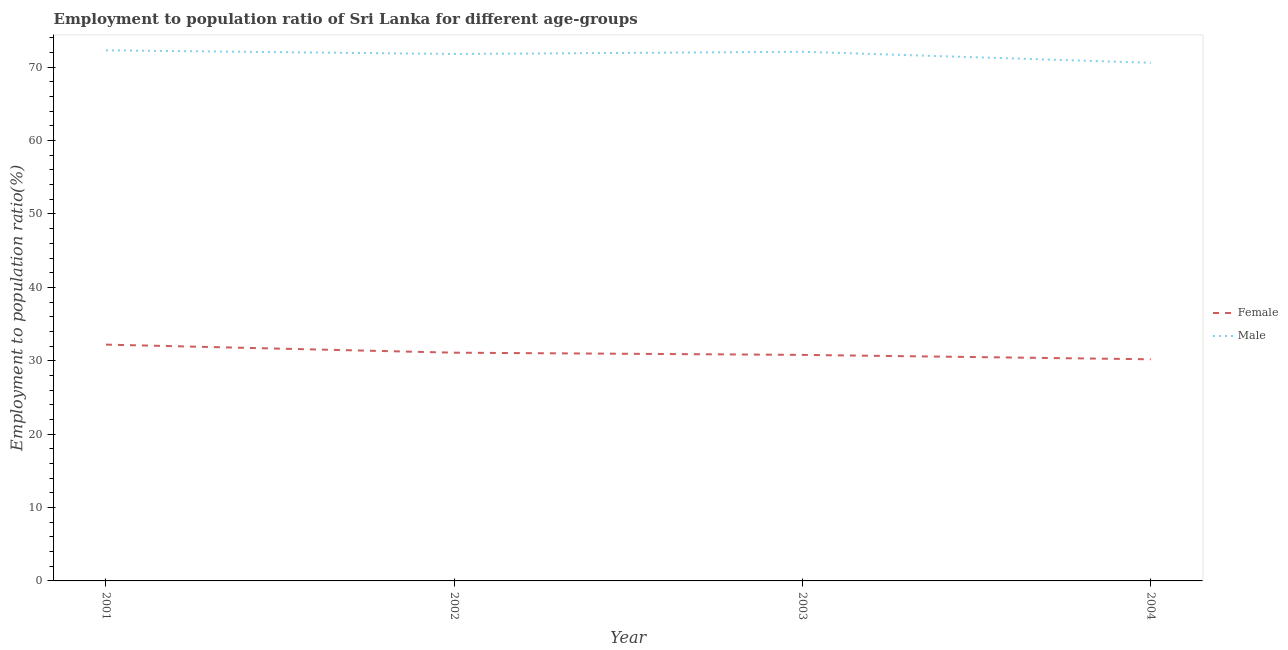How many different coloured lines are there?
Provide a succinct answer. 2. Does the line corresponding to employment to population ratio(female) intersect with the line corresponding to employment to population ratio(male)?
Your answer should be very brief. No. What is the employment to population ratio(male) in 2001?
Your response must be concise. 72.3. Across all years, what is the maximum employment to population ratio(male)?
Provide a short and direct response. 72.3. Across all years, what is the minimum employment to population ratio(male)?
Offer a very short reply. 70.6. In which year was the employment to population ratio(female) maximum?
Offer a terse response. 2001. What is the total employment to population ratio(female) in the graph?
Your response must be concise. 124.3. What is the difference between the employment to population ratio(female) in 2002 and that in 2003?
Provide a short and direct response. 0.3. What is the difference between the employment to population ratio(female) in 2003 and the employment to population ratio(male) in 2002?
Provide a short and direct response. -41. What is the average employment to population ratio(male) per year?
Offer a very short reply. 71.7. In the year 2003, what is the difference between the employment to population ratio(male) and employment to population ratio(female)?
Make the answer very short. 41.3. In how many years, is the employment to population ratio(female) greater than 22 %?
Provide a succinct answer. 4. What is the ratio of the employment to population ratio(male) in 2001 to that in 2002?
Your answer should be very brief. 1.01. Is the difference between the employment to population ratio(male) in 2001 and 2003 greater than the difference between the employment to population ratio(female) in 2001 and 2003?
Give a very brief answer. No. What is the difference between the highest and the second highest employment to population ratio(male)?
Your response must be concise. 0.2. What is the difference between the highest and the lowest employment to population ratio(male)?
Keep it short and to the point. 1.7. How many lines are there?
Offer a very short reply. 2. Does the graph contain grids?
Provide a succinct answer. No. How are the legend labels stacked?
Make the answer very short. Vertical. What is the title of the graph?
Ensure brevity in your answer.  Employment to population ratio of Sri Lanka for different age-groups. Does "From World Bank" appear as one of the legend labels in the graph?
Offer a very short reply. No. What is the label or title of the X-axis?
Your answer should be compact. Year. What is the Employment to population ratio(%) of Female in 2001?
Ensure brevity in your answer.  32.2. What is the Employment to population ratio(%) in Male in 2001?
Offer a very short reply. 72.3. What is the Employment to population ratio(%) in Female in 2002?
Give a very brief answer. 31.1. What is the Employment to population ratio(%) in Male in 2002?
Provide a succinct answer. 71.8. What is the Employment to population ratio(%) of Female in 2003?
Provide a succinct answer. 30.8. What is the Employment to population ratio(%) of Male in 2003?
Keep it short and to the point. 72.1. What is the Employment to population ratio(%) of Female in 2004?
Your response must be concise. 30.2. What is the Employment to population ratio(%) in Male in 2004?
Your response must be concise. 70.6. Across all years, what is the maximum Employment to population ratio(%) in Female?
Make the answer very short. 32.2. Across all years, what is the maximum Employment to population ratio(%) of Male?
Keep it short and to the point. 72.3. Across all years, what is the minimum Employment to population ratio(%) of Female?
Offer a terse response. 30.2. Across all years, what is the minimum Employment to population ratio(%) in Male?
Give a very brief answer. 70.6. What is the total Employment to population ratio(%) in Female in the graph?
Your answer should be very brief. 124.3. What is the total Employment to population ratio(%) in Male in the graph?
Ensure brevity in your answer.  286.8. What is the difference between the Employment to population ratio(%) in Male in 2001 and that in 2003?
Your answer should be compact. 0.2. What is the difference between the Employment to population ratio(%) of Female in 2001 and that in 2004?
Keep it short and to the point. 2. What is the difference between the Employment to population ratio(%) in Male in 2001 and that in 2004?
Provide a short and direct response. 1.7. What is the difference between the Employment to population ratio(%) in Female in 2002 and that in 2003?
Offer a terse response. 0.3. What is the difference between the Employment to population ratio(%) of Male in 2002 and that in 2003?
Make the answer very short. -0.3. What is the difference between the Employment to population ratio(%) in Male in 2002 and that in 2004?
Offer a terse response. 1.2. What is the difference between the Employment to population ratio(%) of Male in 2003 and that in 2004?
Make the answer very short. 1.5. What is the difference between the Employment to population ratio(%) of Female in 2001 and the Employment to population ratio(%) of Male in 2002?
Offer a terse response. -39.6. What is the difference between the Employment to population ratio(%) in Female in 2001 and the Employment to population ratio(%) in Male in 2003?
Offer a very short reply. -39.9. What is the difference between the Employment to population ratio(%) of Female in 2001 and the Employment to population ratio(%) of Male in 2004?
Offer a very short reply. -38.4. What is the difference between the Employment to population ratio(%) in Female in 2002 and the Employment to population ratio(%) in Male in 2003?
Give a very brief answer. -41. What is the difference between the Employment to population ratio(%) of Female in 2002 and the Employment to population ratio(%) of Male in 2004?
Make the answer very short. -39.5. What is the difference between the Employment to population ratio(%) in Female in 2003 and the Employment to population ratio(%) in Male in 2004?
Your response must be concise. -39.8. What is the average Employment to population ratio(%) of Female per year?
Make the answer very short. 31.07. What is the average Employment to population ratio(%) in Male per year?
Provide a short and direct response. 71.7. In the year 2001, what is the difference between the Employment to population ratio(%) of Female and Employment to population ratio(%) of Male?
Provide a succinct answer. -40.1. In the year 2002, what is the difference between the Employment to population ratio(%) of Female and Employment to population ratio(%) of Male?
Your answer should be compact. -40.7. In the year 2003, what is the difference between the Employment to population ratio(%) of Female and Employment to population ratio(%) of Male?
Provide a short and direct response. -41.3. In the year 2004, what is the difference between the Employment to population ratio(%) in Female and Employment to population ratio(%) in Male?
Keep it short and to the point. -40.4. What is the ratio of the Employment to population ratio(%) in Female in 2001 to that in 2002?
Keep it short and to the point. 1.04. What is the ratio of the Employment to population ratio(%) in Male in 2001 to that in 2002?
Offer a very short reply. 1.01. What is the ratio of the Employment to population ratio(%) in Female in 2001 to that in 2003?
Make the answer very short. 1.05. What is the ratio of the Employment to population ratio(%) in Female in 2001 to that in 2004?
Provide a succinct answer. 1.07. What is the ratio of the Employment to population ratio(%) in Male in 2001 to that in 2004?
Give a very brief answer. 1.02. What is the ratio of the Employment to population ratio(%) of Female in 2002 to that in 2003?
Your response must be concise. 1.01. What is the ratio of the Employment to population ratio(%) of Female in 2002 to that in 2004?
Keep it short and to the point. 1.03. What is the ratio of the Employment to population ratio(%) of Male in 2002 to that in 2004?
Ensure brevity in your answer.  1.02. What is the ratio of the Employment to population ratio(%) in Female in 2003 to that in 2004?
Make the answer very short. 1.02. What is the ratio of the Employment to population ratio(%) in Male in 2003 to that in 2004?
Your response must be concise. 1.02. What is the difference between the highest and the second highest Employment to population ratio(%) of Female?
Provide a succinct answer. 1.1. What is the difference between the highest and the second highest Employment to population ratio(%) in Male?
Your answer should be compact. 0.2. 